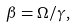Convert formula to latex. <formula><loc_0><loc_0><loc_500><loc_500>\beta = \Omega / \gamma ,</formula> 